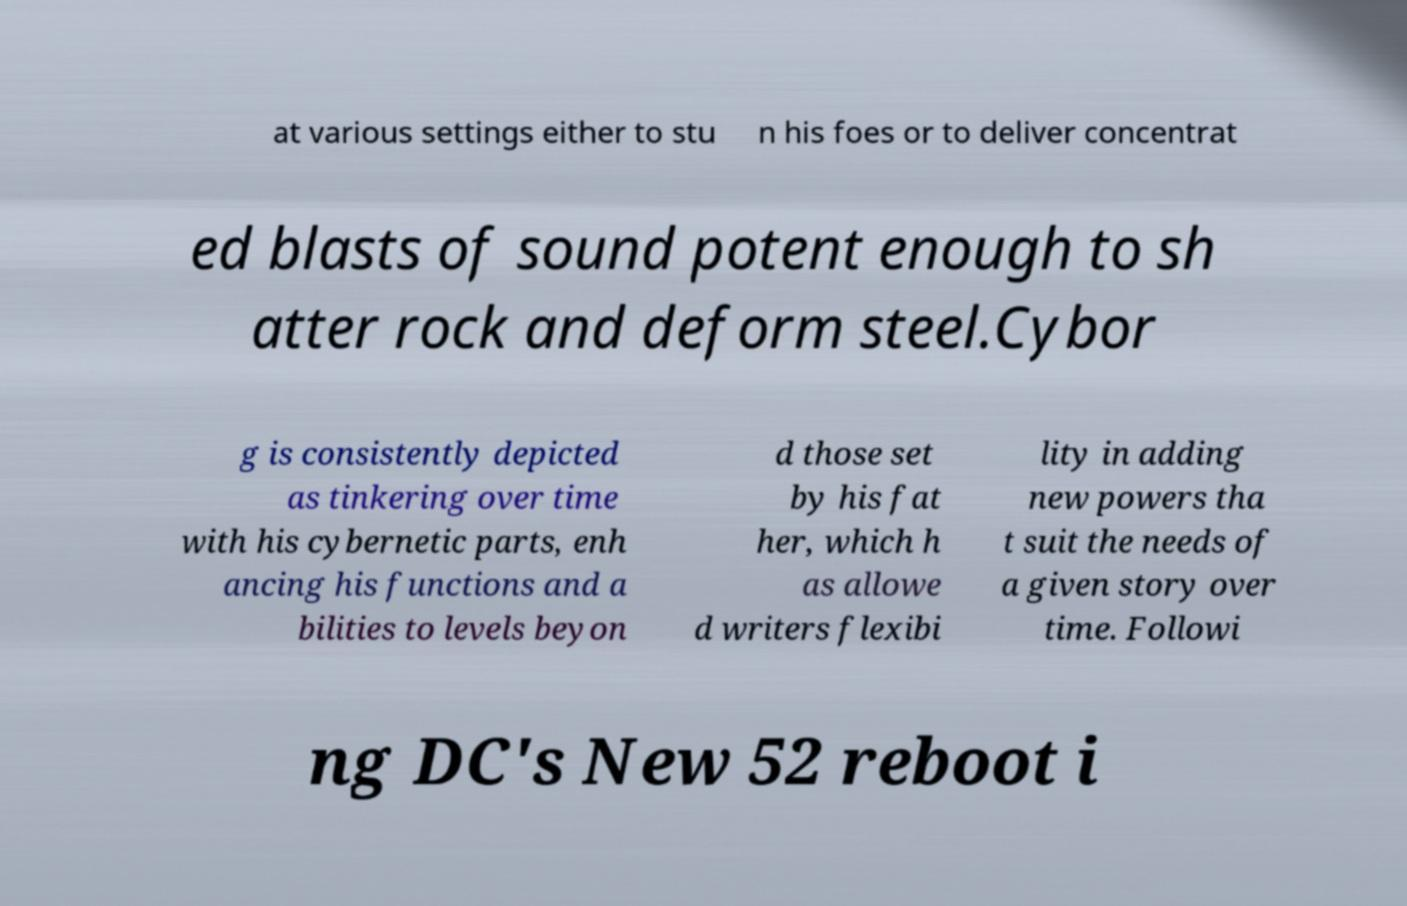Please read and relay the text visible in this image. What does it say? at various settings either to stu n his foes or to deliver concentrat ed blasts of sound potent enough to sh atter rock and deform steel.Cybor g is consistently depicted as tinkering over time with his cybernetic parts, enh ancing his functions and a bilities to levels beyon d those set by his fat her, which h as allowe d writers flexibi lity in adding new powers tha t suit the needs of a given story over time. Followi ng DC's New 52 reboot i 